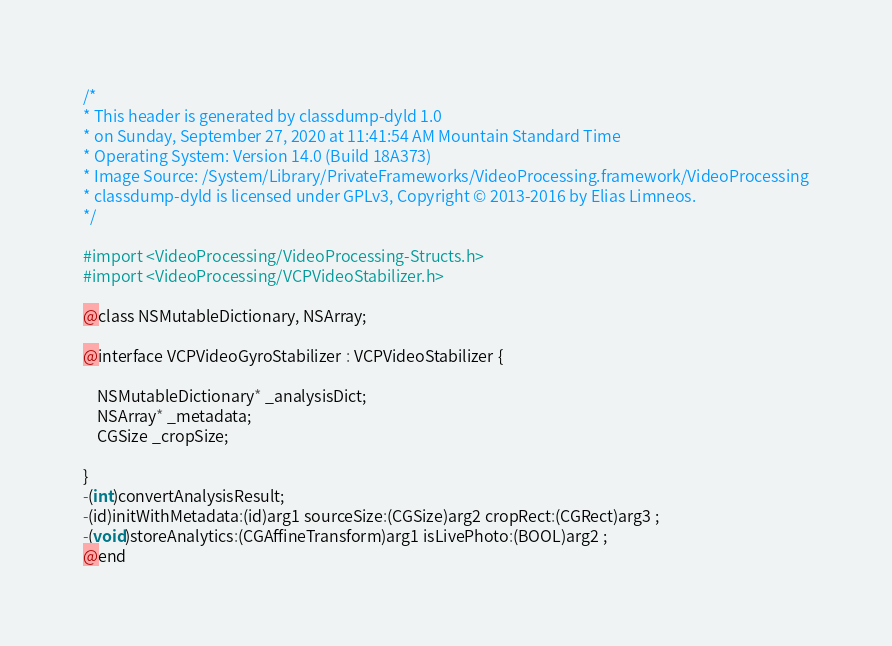<code> <loc_0><loc_0><loc_500><loc_500><_C_>/*
* This header is generated by classdump-dyld 1.0
* on Sunday, September 27, 2020 at 11:41:54 AM Mountain Standard Time
* Operating System: Version 14.0 (Build 18A373)
* Image Source: /System/Library/PrivateFrameworks/VideoProcessing.framework/VideoProcessing
* classdump-dyld is licensed under GPLv3, Copyright © 2013-2016 by Elias Limneos.
*/

#import <VideoProcessing/VideoProcessing-Structs.h>
#import <VideoProcessing/VCPVideoStabilizer.h>

@class NSMutableDictionary, NSArray;

@interface VCPVideoGyroStabilizer : VCPVideoStabilizer {

	NSMutableDictionary* _analysisDict;
	NSArray* _metadata;
	CGSize _cropSize;

}
-(int)convertAnalysisResult;
-(id)initWithMetadata:(id)arg1 sourceSize:(CGSize)arg2 cropRect:(CGRect)arg3 ;
-(void)storeAnalytics:(CGAffineTransform)arg1 isLivePhoto:(BOOL)arg2 ;
@end

</code> 